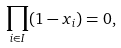<formula> <loc_0><loc_0><loc_500><loc_500>\prod _ { i \in I } ( 1 - x _ { i } ) = 0 ,</formula> 